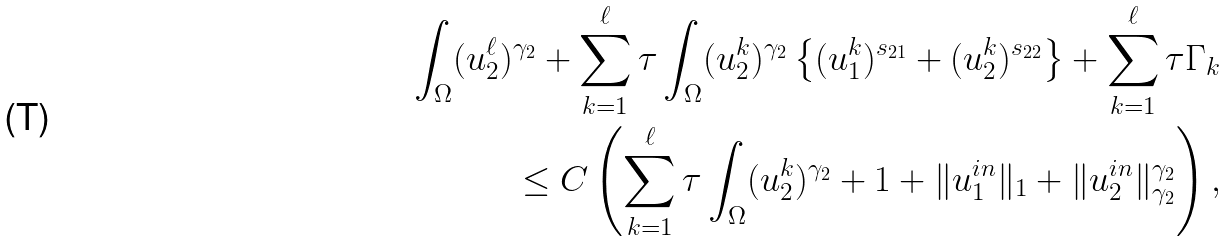Convert formula to latex. <formula><loc_0><loc_0><loc_500><loc_500>\int _ { \Omega } ( u _ { 2 } ^ { \ell } ) ^ { \gamma _ { 2 } } + \sum _ { k = 1 } ^ { \ell } \tau \int _ { \Omega } ( u _ { 2 } ^ { k } ) ^ { \gamma _ { 2 } } \left \{ ( u _ { 1 } ^ { k } ) ^ { s _ { 2 1 } } + ( u _ { 2 } ^ { k } ) ^ { s _ { 2 2 } } \right \} + \sum _ { k = 1 } ^ { \ell } \tau \Gamma _ { k } \\ \leq C \left ( \sum _ { k = 1 } ^ { \ell } \tau \int _ { \Omega } ( u _ { 2 } ^ { k } ) ^ { \gamma _ { 2 } } + 1 + \| u _ { 1 } ^ { i n } \| _ { 1 } + \| u _ { 2 } ^ { i n } \| _ { \gamma _ { 2 } } ^ { \gamma _ { 2 } } \right ) ,</formula> 